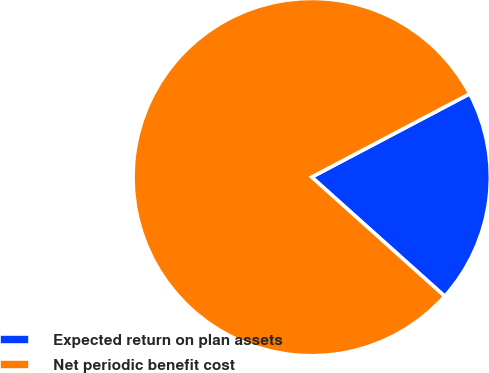Convert chart to OTSL. <chart><loc_0><loc_0><loc_500><loc_500><pie_chart><fcel>Expected return on plan assets<fcel>Net periodic benefit cost<nl><fcel>19.35%<fcel>80.65%<nl></chart> 